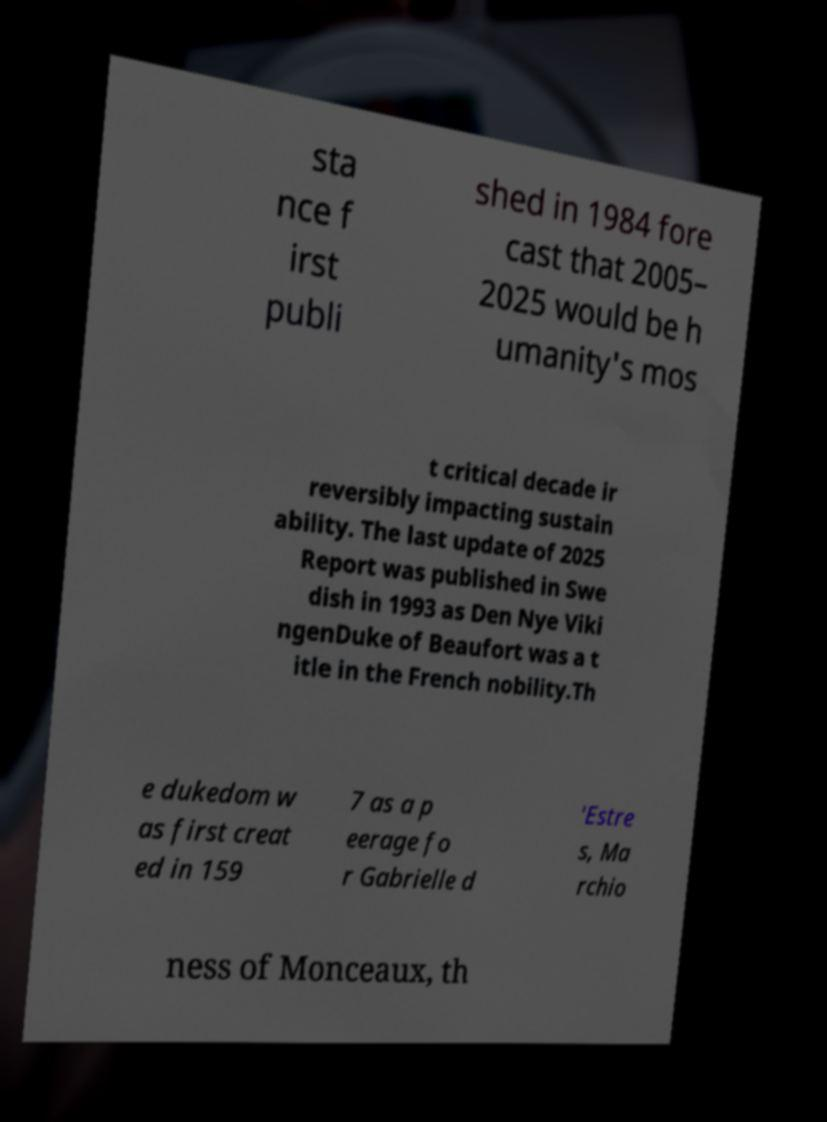What messages or text are displayed in this image? I need them in a readable, typed format. sta nce f irst publi shed in 1984 fore cast that 2005– 2025 would be h umanity's mos t critical decade ir reversibly impacting sustain ability. The last update of 2025 Report was published in Swe dish in 1993 as Den Nye Viki ngenDuke of Beaufort was a t itle in the French nobility.Th e dukedom w as first creat ed in 159 7 as a p eerage fo r Gabrielle d 'Estre s, Ma rchio ness of Monceaux, th 